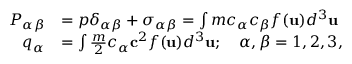<formula> <loc_0><loc_0><loc_500><loc_500>\begin{array} { r l } { P _ { \alpha \beta } } & { = p \delta _ { \alpha \beta } + \sigma _ { \alpha \beta } = \int m c _ { \alpha } c _ { \beta } f ( u ) d ^ { 3 } u } \\ { q _ { \alpha } } & { = \int \frac { m } { 2 } c _ { \alpha } c ^ { 2 } f ( u ) d ^ { 3 } u ; \quad \alpha , \beta = 1 , 2 , 3 , } \end{array}</formula> 